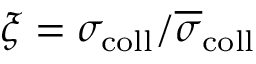<formula> <loc_0><loc_0><loc_500><loc_500>\xi = \sigma _ { c o l l } / \overline { \sigma } _ { c o l l }</formula> 